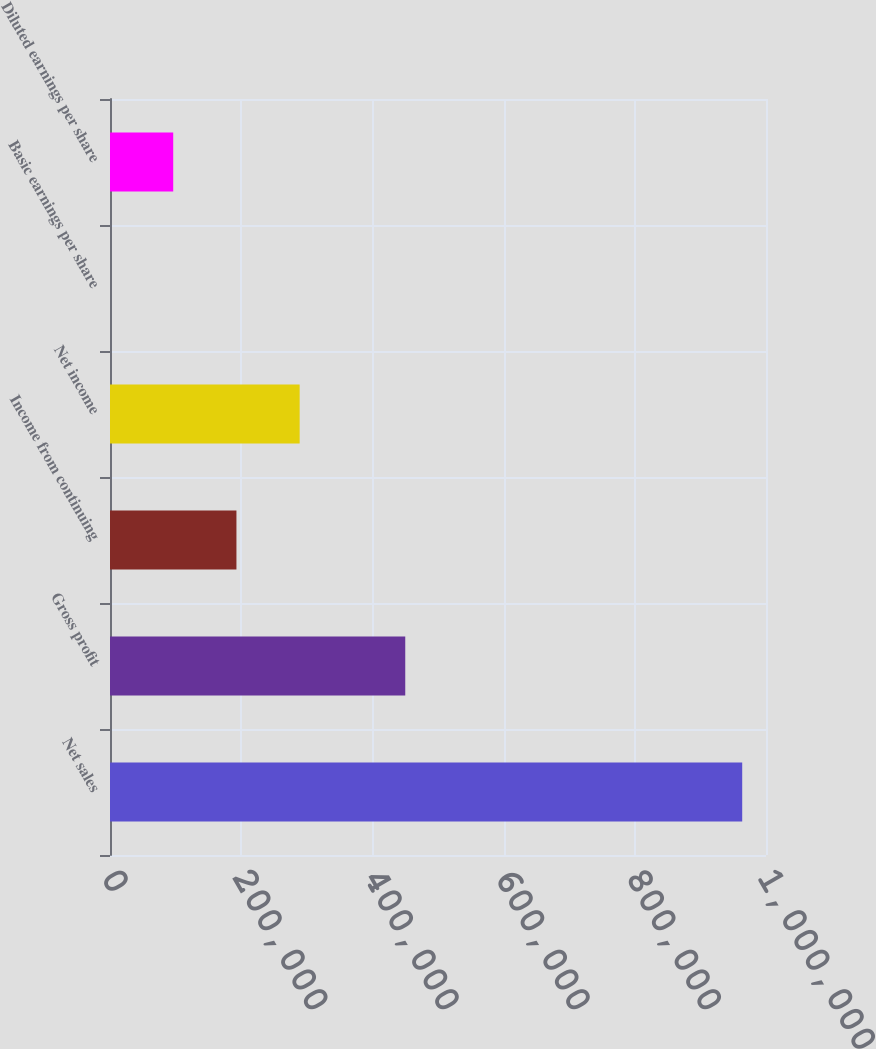Convert chart to OTSL. <chart><loc_0><loc_0><loc_500><loc_500><bar_chart><fcel>Net sales<fcel>Gross profit<fcel>Income from continuing<fcel>Net income<fcel>Basic earnings per share<fcel>Diluted earnings per share<nl><fcel>963725<fcel>450082<fcel>192745<fcel>289118<fcel>0.36<fcel>96372.8<nl></chart> 